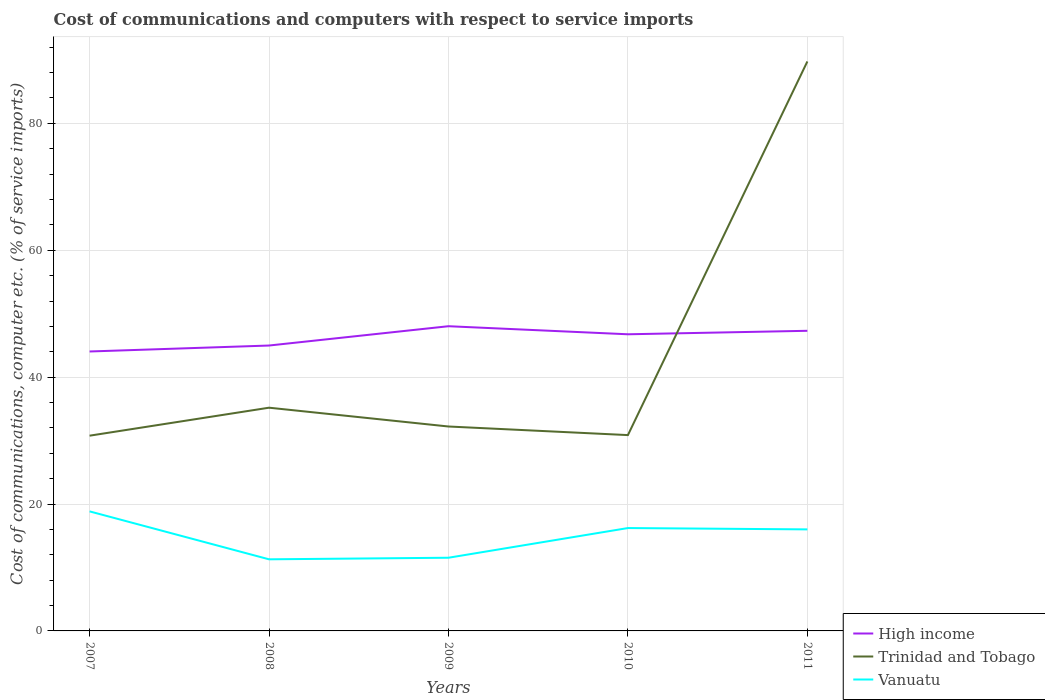Across all years, what is the maximum cost of communications and computers in Vanuatu?
Offer a terse response. 11.29. What is the total cost of communications and computers in Vanuatu in the graph?
Make the answer very short. 0.21. What is the difference between the highest and the second highest cost of communications and computers in High income?
Ensure brevity in your answer.  3.98. How many lines are there?
Offer a very short reply. 3. Are the values on the major ticks of Y-axis written in scientific E-notation?
Provide a short and direct response. No. Where does the legend appear in the graph?
Keep it short and to the point. Bottom right. How many legend labels are there?
Make the answer very short. 3. How are the legend labels stacked?
Give a very brief answer. Vertical. What is the title of the graph?
Your response must be concise. Cost of communications and computers with respect to service imports. Does "Venezuela" appear as one of the legend labels in the graph?
Keep it short and to the point. No. What is the label or title of the Y-axis?
Your response must be concise. Cost of communications, computer etc. (% of service imports). What is the Cost of communications, computer etc. (% of service imports) in High income in 2007?
Keep it short and to the point. 44.04. What is the Cost of communications, computer etc. (% of service imports) of Trinidad and Tobago in 2007?
Offer a terse response. 30.77. What is the Cost of communications, computer etc. (% of service imports) of Vanuatu in 2007?
Provide a short and direct response. 18.84. What is the Cost of communications, computer etc. (% of service imports) of High income in 2008?
Make the answer very short. 44.98. What is the Cost of communications, computer etc. (% of service imports) in Trinidad and Tobago in 2008?
Provide a succinct answer. 35.18. What is the Cost of communications, computer etc. (% of service imports) of Vanuatu in 2008?
Give a very brief answer. 11.29. What is the Cost of communications, computer etc. (% of service imports) in High income in 2009?
Offer a very short reply. 48.03. What is the Cost of communications, computer etc. (% of service imports) of Trinidad and Tobago in 2009?
Offer a terse response. 32.22. What is the Cost of communications, computer etc. (% of service imports) of Vanuatu in 2009?
Your answer should be compact. 11.53. What is the Cost of communications, computer etc. (% of service imports) of High income in 2010?
Offer a very short reply. 46.76. What is the Cost of communications, computer etc. (% of service imports) in Trinidad and Tobago in 2010?
Your response must be concise. 30.87. What is the Cost of communications, computer etc. (% of service imports) in Vanuatu in 2010?
Offer a very short reply. 16.21. What is the Cost of communications, computer etc. (% of service imports) in High income in 2011?
Provide a succinct answer. 47.3. What is the Cost of communications, computer etc. (% of service imports) of Trinidad and Tobago in 2011?
Offer a terse response. 89.76. What is the Cost of communications, computer etc. (% of service imports) in Vanuatu in 2011?
Give a very brief answer. 16. Across all years, what is the maximum Cost of communications, computer etc. (% of service imports) in High income?
Make the answer very short. 48.03. Across all years, what is the maximum Cost of communications, computer etc. (% of service imports) in Trinidad and Tobago?
Make the answer very short. 89.76. Across all years, what is the maximum Cost of communications, computer etc. (% of service imports) in Vanuatu?
Provide a short and direct response. 18.84. Across all years, what is the minimum Cost of communications, computer etc. (% of service imports) of High income?
Offer a very short reply. 44.04. Across all years, what is the minimum Cost of communications, computer etc. (% of service imports) of Trinidad and Tobago?
Your answer should be compact. 30.77. Across all years, what is the minimum Cost of communications, computer etc. (% of service imports) in Vanuatu?
Offer a terse response. 11.29. What is the total Cost of communications, computer etc. (% of service imports) of High income in the graph?
Your answer should be compact. 231.11. What is the total Cost of communications, computer etc. (% of service imports) of Trinidad and Tobago in the graph?
Your answer should be very brief. 218.8. What is the total Cost of communications, computer etc. (% of service imports) of Vanuatu in the graph?
Make the answer very short. 73.88. What is the difference between the Cost of communications, computer etc. (% of service imports) in High income in 2007 and that in 2008?
Your answer should be compact. -0.94. What is the difference between the Cost of communications, computer etc. (% of service imports) in Trinidad and Tobago in 2007 and that in 2008?
Make the answer very short. -4.41. What is the difference between the Cost of communications, computer etc. (% of service imports) in Vanuatu in 2007 and that in 2008?
Provide a succinct answer. 7.56. What is the difference between the Cost of communications, computer etc. (% of service imports) of High income in 2007 and that in 2009?
Offer a very short reply. -3.98. What is the difference between the Cost of communications, computer etc. (% of service imports) of Trinidad and Tobago in 2007 and that in 2009?
Your answer should be very brief. -1.45. What is the difference between the Cost of communications, computer etc. (% of service imports) in Vanuatu in 2007 and that in 2009?
Offer a very short reply. 7.31. What is the difference between the Cost of communications, computer etc. (% of service imports) of High income in 2007 and that in 2010?
Your answer should be very brief. -2.71. What is the difference between the Cost of communications, computer etc. (% of service imports) of Trinidad and Tobago in 2007 and that in 2010?
Keep it short and to the point. -0.09. What is the difference between the Cost of communications, computer etc. (% of service imports) in Vanuatu in 2007 and that in 2010?
Give a very brief answer. 2.63. What is the difference between the Cost of communications, computer etc. (% of service imports) of High income in 2007 and that in 2011?
Offer a terse response. -3.26. What is the difference between the Cost of communications, computer etc. (% of service imports) of Trinidad and Tobago in 2007 and that in 2011?
Your answer should be very brief. -58.98. What is the difference between the Cost of communications, computer etc. (% of service imports) of Vanuatu in 2007 and that in 2011?
Make the answer very short. 2.84. What is the difference between the Cost of communications, computer etc. (% of service imports) of High income in 2008 and that in 2009?
Your answer should be very brief. -3.04. What is the difference between the Cost of communications, computer etc. (% of service imports) of Trinidad and Tobago in 2008 and that in 2009?
Offer a very short reply. 2.96. What is the difference between the Cost of communications, computer etc. (% of service imports) in Vanuatu in 2008 and that in 2009?
Your response must be concise. -0.25. What is the difference between the Cost of communications, computer etc. (% of service imports) of High income in 2008 and that in 2010?
Give a very brief answer. -1.77. What is the difference between the Cost of communications, computer etc. (% of service imports) in Trinidad and Tobago in 2008 and that in 2010?
Make the answer very short. 4.32. What is the difference between the Cost of communications, computer etc. (% of service imports) in Vanuatu in 2008 and that in 2010?
Offer a very short reply. -4.93. What is the difference between the Cost of communications, computer etc. (% of service imports) of High income in 2008 and that in 2011?
Offer a very short reply. -2.32. What is the difference between the Cost of communications, computer etc. (% of service imports) in Trinidad and Tobago in 2008 and that in 2011?
Offer a terse response. -54.57. What is the difference between the Cost of communications, computer etc. (% of service imports) of Vanuatu in 2008 and that in 2011?
Your answer should be very brief. -4.72. What is the difference between the Cost of communications, computer etc. (% of service imports) of High income in 2009 and that in 2010?
Provide a succinct answer. 1.27. What is the difference between the Cost of communications, computer etc. (% of service imports) of Trinidad and Tobago in 2009 and that in 2010?
Offer a terse response. 1.35. What is the difference between the Cost of communications, computer etc. (% of service imports) of Vanuatu in 2009 and that in 2010?
Your answer should be very brief. -4.68. What is the difference between the Cost of communications, computer etc. (% of service imports) of High income in 2009 and that in 2011?
Your answer should be very brief. 0.72. What is the difference between the Cost of communications, computer etc. (% of service imports) of Trinidad and Tobago in 2009 and that in 2011?
Your answer should be very brief. -57.53. What is the difference between the Cost of communications, computer etc. (% of service imports) in Vanuatu in 2009 and that in 2011?
Offer a very short reply. -4.47. What is the difference between the Cost of communications, computer etc. (% of service imports) in High income in 2010 and that in 2011?
Offer a terse response. -0.55. What is the difference between the Cost of communications, computer etc. (% of service imports) in Trinidad and Tobago in 2010 and that in 2011?
Your answer should be compact. -58.89. What is the difference between the Cost of communications, computer etc. (% of service imports) of Vanuatu in 2010 and that in 2011?
Offer a very short reply. 0.21. What is the difference between the Cost of communications, computer etc. (% of service imports) in High income in 2007 and the Cost of communications, computer etc. (% of service imports) in Trinidad and Tobago in 2008?
Provide a short and direct response. 8.86. What is the difference between the Cost of communications, computer etc. (% of service imports) of High income in 2007 and the Cost of communications, computer etc. (% of service imports) of Vanuatu in 2008?
Provide a short and direct response. 32.76. What is the difference between the Cost of communications, computer etc. (% of service imports) in Trinidad and Tobago in 2007 and the Cost of communications, computer etc. (% of service imports) in Vanuatu in 2008?
Offer a terse response. 19.49. What is the difference between the Cost of communications, computer etc. (% of service imports) in High income in 2007 and the Cost of communications, computer etc. (% of service imports) in Trinidad and Tobago in 2009?
Offer a very short reply. 11.82. What is the difference between the Cost of communications, computer etc. (% of service imports) of High income in 2007 and the Cost of communications, computer etc. (% of service imports) of Vanuatu in 2009?
Keep it short and to the point. 32.51. What is the difference between the Cost of communications, computer etc. (% of service imports) in Trinidad and Tobago in 2007 and the Cost of communications, computer etc. (% of service imports) in Vanuatu in 2009?
Your answer should be very brief. 19.24. What is the difference between the Cost of communications, computer etc. (% of service imports) in High income in 2007 and the Cost of communications, computer etc. (% of service imports) in Trinidad and Tobago in 2010?
Your response must be concise. 13.18. What is the difference between the Cost of communications, computer etc. (% of service imports) in High income in 2007 and the Cost of communications, computer etc. (% of service imports) in Vanuatu in 2010?
Provide a short and direct response. 27.83. What is the difference between the Cost of communications, computer etc. (% of service imports) of Trinidad and Tobago in 2007 and the Cost of communications, computer etc. (% of service imports) of Vanuatu in 2010?
Give a very brief answer. 14.56. What is the difference between the Cost of communications, computer etc. (% of service imports) in High income in 2007 and the Cost of communications, computer etc. (% of service imports) in Trinidad and Tobago in 2011?
Your answer should be compact. -45.71. What is the difference between the Cost of communications, computer etc. (% of service imports) in High income in 2007 and the Cost of communications, computer etc. (% of service imports) in Vanuatu in 2011?
Your response must be concise. 28.04. What is the difference between the Cost of communications, computer etc. (% of service imports) in Trinidad and Tobago in 2007 and the Cost of communications, computer etc. (% of service imports) in Vanuatu in 2011?
Ensure brevity in your answer.  14.77. What is the difference between the Cost of communications, computer etc. (% of service imports) of High income in 2008 and the Cost of communications, computer etc. (% of service imports) of Trinidad and Tobago in 2009?
Offer a very short reply. 12.76. What is the difference between the Cost of communications, computer etc. (% of service imports) in High income in 2008 and the Cost of communications, computer etc. (% of service imports) in Vanuatu in 2009?
Give a very brief answer. 33.45. What is the difference between the Cost of communications, computer etc. (% of service imports) in Trinidad and Tobago in 2008 and the Cost of communications, computer etc. (% of service imports) in Vanuatu in 2009?
Offer a terse response. 23.65. What is the difference between the Cost of communications, computer etc. (% of service imports) of High income in 2008 and the Cost of communications, computer etc. (% of service imports) of Trinidad and Tobago in 2010?
Your answer should be very brief. 14.12. What is the difference between the Cost of communications, computer etc. (% of service imports) in High income in 2008 and the Cost of communications, computer etc. (% of service imports) in Vanuatu in 2010?
Your answer should be compact. 28.77. What is the difference between the Cost of communications, computer etc. (% of service imports) of Trinidad and Tobago in 2008 and the Cost of communications, computer etc. (% of service imports) of Vanuatu in 2010?
Your response must be concise. 18.97. What is the difference between the Cost of communications, computer etc. (% of service imports) in High income in 2008 and the Cost of communications, computer etc. (% of service imports) in Trinidad and Tobago in 2011?
Offer a very short reply. -44.77. What is the difference between the Cost of communications, computer etc. (% of service imports) of High income in 2008 and the Cost of communications, computer etc. (% of service imports) of Vanuatu in 2011?
Keep it short and to the point. 28.98. What is the difference between the Cost of communications, computer etc. (% of service imports) in Trinidad and Tobago in 2008 and the Cost of communications, computer etc. (% of service imports) in Vanuatu in 2011?
Keep it short and to the point. 19.18. What is the difference between the Cost of communications, computer etc. (% of service imports) of High income in 2009 and the Cost of communications, computer etc. (% of service imports) of Trinidad and Tobago in 2010?
Offer a terse response. 17.16. What is the difference between the Cost of communications, computer etc. (% of service imports) of High income in 2009 and the Cost of communications, computer etc. (% of service imports) of Vanuatu in 2010?
Give a very brief answer. 31.81. What is the difference between the Cost of communications, computer etc. (% of service imports) in Trinidad and Tobago in 2009 and the Cost of communications, computer etc. (% of service imports) in Vanuatu in 2010?
Make the answer very short. 16.01. What is the difference between the Cost of communications, computer etc. (% of service imports) of High income in 2009 and the Cost of communications, computer etc. (% of service imports) of Trinidad and Tobago in 2011?
Keep it short and to the point. -41.73. What is the difference between the Cost of communications, computer etc. (% of service imports) of High income in 2009 and the Cost of communications, computer etc. (% of service imports) of Vanuatu in 2011?
Keep it short and to the point. 32.02. What is the difference between the Cost of communications, computer etc. (% of service imports) of Trinidad and Tobago in 2009 and the Cost of communications, computer etc. (% of service imports) of Vanuatu in 2011?
Keep it short and to the point. 16.22. What is the difference between the Cost of communications, computer etc. (% of service imports) of High income in 2010 and the Cost of communications, computer etc. (% of service imports) of Trinidad and Tobago in 2011?
Ensure brevity in your answer.  -43. What is the difference between the Cost of communications, computer etc. (% of service imports) in High income in 2010 and the Cost of communications, computer etc. (% of service imports) in Vanuatu in 2011?
Your response must be concise. 30.75. What is the difference between the Cost of communications, computer etc. (% of service imports) of Trinidad and Tobago in 2010 and the Cost of communications, computer etc. (% of service imports) of Vanuatu in 2011?
Your response must be concise. 14.86. What is the average Cost of communications, computer etc. (% of service imports) in High income per year?
Keep it short and to the point. 46.22. What is the average Cost of communications, computer etc. (% of service imports) of Trinidad and Tobago per year?
Your answer should be compact. 43.76. What is the average Cost of communications, computer etc. (% of service imports) of Vanuatu per year?
Your answer should be very brief. 14.78. In the year 2007, what is the difference between the Cost of communications, computer etc. (% of service imports) in High income and Cost of communications, computer etc. (% of service imports) in Trinidad and Tobago?
Your response must be concise. 13.27. In the year 2007, what is the difference between the Cost of communications, computer etc. (% of service imports) of High income and Cost of communications, computer etc. (% of service imports) of Vanuatu?
Offer a very short reply. 25.2. In the year 2007, what is the difference between the Cost of communications, computer etc. (% of service imports) in Trinidad and Tobago and Cost of communications, computer etc. (% of service imports) in Vanuatu?
Your answer should be very brief. 11.93. In the year 2008, what is the difference between the Cost of communications, computer etc. (% of service imports) in High income and Cost of communications, computer etc. (% of service imports) in Trinidad and Tobago?
Offer a terse response. 9.8. In the year 2008, what is the difference between the Cost of communications, computer etc. (% of service imports) in High income and Cost of communications, computer etc. (% of service imports) in Vanuatu?
Provide a succinct answer. 33.7. In the year 2008, what is the difference between the Cost of communications, computer etc. (% of service imports) of Trinidad and Tobago and Cost of communications, computer etc. (% of service imports) of Vanuatu?
Give a very brief answer. 23.9. In the year 2009, what is the difference between the Cost of communications, computer etc. (% of service imports) in High income and Cost of communications, computer etc. (% of service imports) in Trinidad and Tobago?
Give a very brief answer. 15.81. In the year 2009, what is the difference between the Cost of communications, computer etc. (% of service imports) of High income and Cost of communications, computer etc. (% of service imports) of Vanuatu?
Make the answer very short. 36.49. In the year 2009, what is the difference between the Cost of communications, computer etc. (% of service imports) of Trinidad and Tobago and Cost of communications, computer etc. (% of service imports) of Vanuatu?
Keep it short and to the point. 20.69. In the year 2010, what is the difference between the Cost of communications, computer etc. (% of service imports) in High income and Cost of communications, computer etc. (% of service imports) in Trinidad and Tobago?
Keep it short and to the point. 15.89. In the year 2010, what is the difference between the Cost of communications, computer etc. (% of service imports) in High income and Cost of communications, computer etc. (% of service imports) in Vanuatu?
Provide a succinct answer. 30.54. In the year 2010, what is the difference between the Cost of communications, computer etc. (% of service imports) in Trinidad and Tobago and Cost of communications, computer etc. (% of service imports) in Vanuatu?
Your answer should be compact. 14.65. In the year 2011, what is the difference between the Cost of communications, computer etc. (% of service imports) in High income and Cost of communications, computer etc. (% of service imports) in Trinidad and Tobago?
Provide a short and direct response. -42.45. In the year 2011, what is the difference between the Cost of communications, computer etc. (% of service imports) in High income and Cost of communications, computer etc. (% of service imports) in Vanuatu?
Provide a succinct answer. 31.3. In the year 2011, what is the difference between the Cost of communications, computer etc. (% of service imports) of Trinidad and Tobago and Cost of communications, computer etc. (% of service imports) of Vanuatu?
Provide a short and direct response. 73.75. What is the ratio of the Cost of communications, computer etc. (% of service imports) of High income in 2007 to that in 2008?
Ensure brevity in your answer.  0.98. What is the ratio of the Cost of communications, computer etc. (% of service imports) of Trinidad and Tobago in 2007 to that in 2008?
Provide a succinct answer. 0.87. What is the ratio of the Cost of communications, computer etc. (% of service imports) of Vanuatu in 2007 to that in 2008?
Your answer should be very brief. 1.67. What is the ratio of the Cost of communications, computer etc. (% of service imports) of High income in 2007 to that in 2009?
Your answer should be very brief. 0.92. What is the ratio of the Cost of communications, computer etc. (% of service imports) in Trinidad and Tobago in 2007 to that in 2009?
Ensure brevity in your answer.  0.96. What is the ratio of the Cost of communications, computer etc. (% of service imports) in Vanuatu in 2007 to that in 2009?
Make the answer very short. 1.63. What is the ratio of the Cost of communications, computer etc. (% of service imports) of High income in 2007 to that in 2010?
Provide a short and direct response. 0.94. What is the ratio of the Cost of communications, computer etc. (% of service imports) of Trinidad and Tobago in 2007 to that in 2010?
Keep it short and to the point. 1. What is the ratio of the Cost of communications, computer etc. (% of service imports) in Vanuatu in 2007 to that in 2010?
Give a very brief answer. 1.16. What is the ratio of the Cost of communications, computer etc. (% of service imports) of High income in 2007 to that in 2011?
Ensure brevity in your answer.  0.93. What is the ratio of the Cost of communications, computer etc. (% of service imports) in Trinidad and Tobago in 2007 to that in 2011?
Provide a short and direct response. 0.34. What is the ratio of the Cost of communications, computer etc. (% of service imports) in Vanuatu in 2007 to that in 2011?
Your answer should be compact. 1.18. What is the ratio of the Cost of communications, computer etc. (% of service imports) in High income in 2008 to that in 2009?
Your answer should be compact. 0.94. What is the ratio of the Cost of communications, computer etc. (% of service imports) in Trinidad and Tobago in 2008 to that in 2009?
Your answer should be compact. 1.09. What is the ratio of the Cost of communications, computer etc. (% of service imports) of Vanuatu in 2008 to that in 2009?
Offer a very short reply. 0.98. What is the ratio of the Cost of communications, computer etc. (% of service imports) in High income in 2008 to that in 2010?
Give a very brief answer. 0.96. What is the ratio of the Cost of communications, computer etc. (% of service imports) of Trinidad and Tobago in 2008 to that in 2010?
Your answer should be very brief. 1.14. What is the ratio of the Cost of communications, computer etc. (% of service imports) of Vanuatu in 2008 to that in 2010?
Your answer should be compact. 0.7. What is the ratio of the Cost of communications, computer etc. (% of service imports) in High income in 2008 to that in 2011?
Offer a terse response. 0.95. What is the ratio of the Cost of communications, computer etc. (% of service imports) of Trinidad and Tobago in 2008 to that in 2011?
Ensure brevity in your answer.  0.39. What is the ratio of the Cost of communications, computer etc. (% of service imports) of Vanuatu in 2008 to that in 2011?
Offer a terse response. 0.71. What is the ratio of the Cost of communications, computer etc. (% of service imports) of High income in 2009 to that in 2010?
Provide a short and direct response. 1.03. What is the ratio of the Cost of communications, computer etc. (% of service imports) in Trinidad and Tobago in 2009 to that in 2010?
Ensure brevity in your answer.  1.04. What is the ratio of the Cost of communications, computer etc. (% of service imports) in Vanuatu in 2009 to that in 2010?
Offer a terse response. 0.71. What is the ratio of the Cost of communications, computer etc. (% of service imports) in High income in 2009 to that in 2011?
Keep it short and to the point. 1.02. What is the ratio of the Cost of communications, computer etc. (% of service imports) in Trinidad and Tobago in 2009 to that in 2011?
Provide a succinct answer. 0.36. What is the ratio of the Cost of communications, computer etc. (% of service imports) of Vanuatu in 2009 to that in 2011?
Keep it short and to the point. 0.72. What is the ratio of the Cost of communications, computer etc. (% of service imports) of High income in 2010 to that in 2011?
Your response must be concise. 0.99. What is the ratio of the Cost of communications, computer etc. (% of service imports) of Trinidad and Tobago in 2010 to that in 2011?
Offer a very short reply. 0.34. What is the ratio of the Cost of communications, computer etc. (% of service imports) in Vanuatu in 2010 to that in 2011?
Offer a very short reply. 1.01. What is the difference between the highest and the second highest Cost of communications, computer etc. (% of service imports) in High income?
Keep it short and to the point. 0.72. What is the difference between the highest and the second highest Cost of communications, computer etc. (% of service imports) in Trinidad and Tobago?
Ensure brevity in your answer.  54.57. What is the difference between the highest and the second highest Cost of communications, computer etc. (% of service imports) in Vanuatu?
Your response must be concise. 2.63. What is the difference between the highest and the lowest Cost of communications, computer etc. (% of service imports) of High income?
Provide a succinct answer. 3.98. What is the difference between the highest and the lowest Cost of communications, computer etc. (% of service imports) in Trinidad and Tobago?
Your answer should be compact. 58.98. What is the difference between the highest and the lowest Cost of communications, computer etc. (% of service imports) of Vanuatu?
Provide a short and direct response. 7.56. 